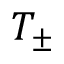<formula> <loc_0><loc_0><loc_500><loc_500>T _ { \pm }</formula> 